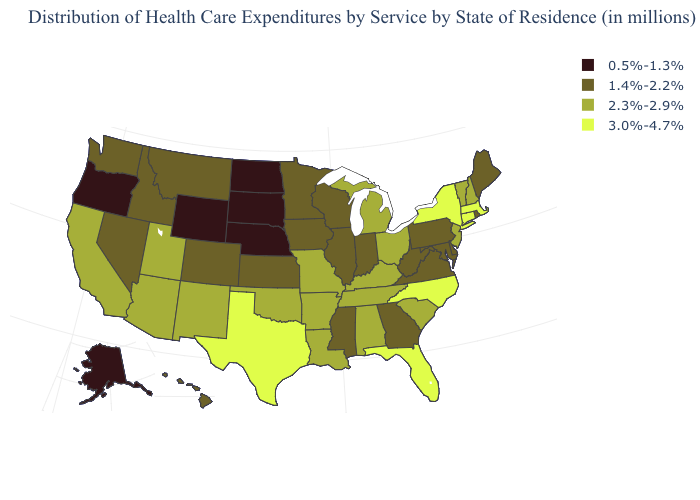What is the value of North Carolina?
Keep it brief. 3.0%-4.7%. Does the first symbol in the legend represent the smallest category?
Be succinct. Yes. What is the value of Utah?
Write a very short answer. 2.3%-2.9%. What is the value of Idaho?
Write a very short answer. 1.4%-2.2%. Which states have the highest value in the USA?
Be succinct. Connecticut, Florida, Massachusetts, New York, North Carolina, Texas. What is the lowest value in states that border Missouri?
Quick response, please. 0.5%-1.3%. Name the states that have a value in the range 1.4%-2.2%?
Concise answer only. Colorado, Delaware, Georgia, Hawaii, Idaho, Illinois, Indiana, Iowa, Kansas, Maine, Maryland, Minnesota, Mississippi, Montana, Nevada, Pennsylvania, Rhode Island, Virginia, Washington, West Virginia, Wisconsin. Which states hav the highest value in the West?
Keep it brief. Arizona, California, New Mexico, Utah. Name the states that have a value in the range 0.5%-1.3%?
Be succinct. Alaska, Nebraska, North Dakota, Oregon, South Dakota, Wyoming. Name the states that have a value in the range 3.0%-4.7%?
Be succinct. Connecticut, Florida, Massachusetts, New York, North Carolina, Texas. What is the lowest value in the South?
Answer briefly. 1.4%-2.2%. Name the states that have a value in the range 1.4%-2.2%?
Give a very brief answer. Colorado, Delaware, Georgia, Hawaii, Idaho, Illinois, Indiana, Iowa, Kansas, Maine, Maryland, Minnesota, Mississippi, Montana, Nevada, Pennsylvania, Rhode Island, Virginia, Washington, West Virginia, Wisconsin. What is the value of New Mexico?
Give a very brief answer. 2.3%-2.9%. How many symbols are there in the legend?
Give a very brief answer. 4. 